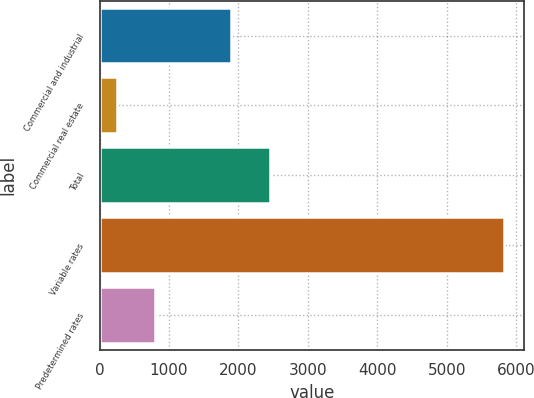<chart> <loc_0><loc_0><loc_500><loc_500><bar_chart><fcel>Commercial and industrial<fcel>Commercial real estate<fcel>Total<fcel>Variable rates<fcel>Predetermined rates<nl><fcel>1893.3<fcel>246.3<fcel>2450.86<fcel>5821.9<fcel>803.86<nl></chart> 